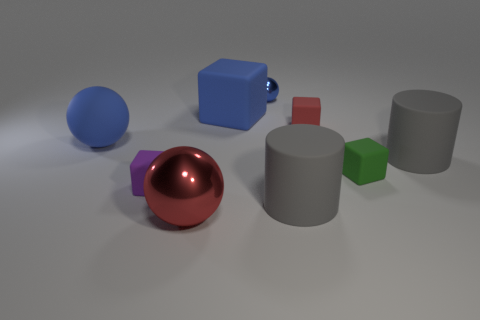There is a cube that is the same color as the big shiny ball; what material is it?
Offer a terse response. Rubber. The ball in front of the blue sphere in front of the small blue metallic sphere is what color?
Provide a succinct answer. Red. Is the red shiny ball the same size as the blue matte ball?
Offer a terse response. Yes. There is a red thing that is the same shape as the small purple rubber object; what material is it?
Provide a succinct answer. Rubber. How many gray blocks are the same size as the red block?
Provide a succinct answer. 0. There is a sphere that is the same material as the red block; what is its color?
Ensure brevity in your answer.  Blue. Is the number of metallic cylinders less than the number of big blue blocks?
Give a very brief answer. Yes. How many gray things are either large objects or big balls?
Offer a very short reply. 2. What number of rubber objects are behind the tiny green thing and on the right side of the red shiny thing?
Ensure brevity in your answer.  3. Does the tiny blue sphere have the same material as the large blue cube?
Provide a succinct answer. No. 